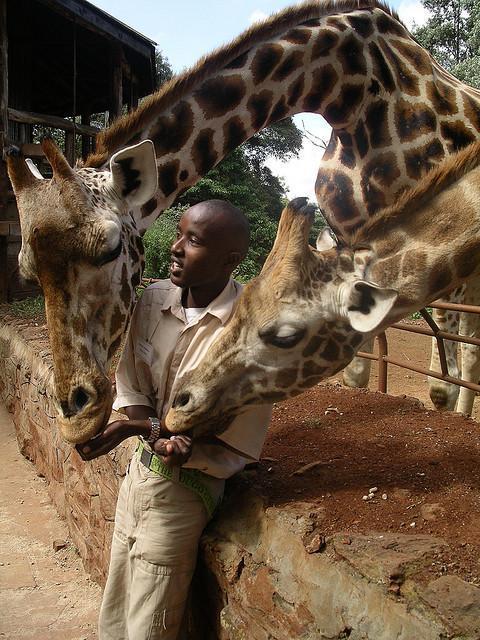How many giraffes are in this photo?
Give a very brief answer. 2. How many giraffes can be seen?
Give a very brief answer. 2. How many sheep are there?
Give a very brief answer. 0. 